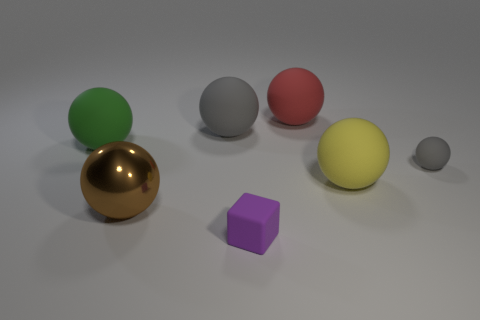Subtract all large yellow matte spheres. How many spheres are left? 5 Subtract all red balls. How many balls are left? 5 Add 2 big blue metal cylinders. How many objects exist? 9 Subtract all green balls. Subtract all red cubes. How many balls are left? 5 Subtract all cubes. How many objects are left? 6 Subtract 0 purple balls. How many objects are left? 7 Subtract all brown metal things. Subtract all purple blocks. How many objects are left? 5 Add 5 big green balls. How many big green balls are left? 6 Add 2 gray balls. How many gray balls exist? 4 